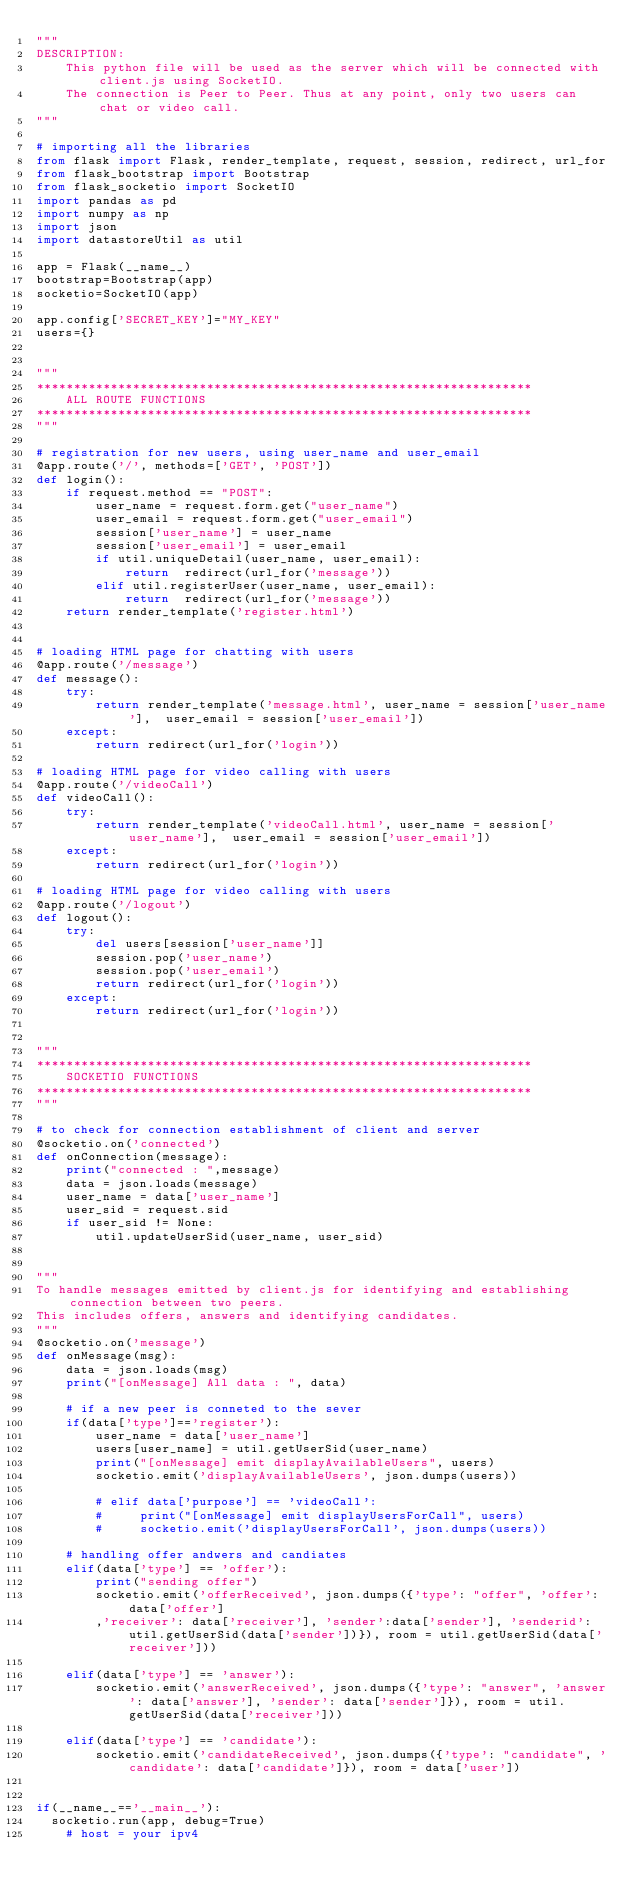<code> <loc_0><loc_0><loc_500><loc_500><_Python_>"""
DESCRIPTION:
    This python file will be used as the server which will be connected with client.js using SocketIO.
    The connection is Peer to Peer. Thus at any point, only two users can chat or video call. 
"""

# importing all the libraries
from flask import Flask, render_template, request, session, redirect, url_for
from flask_bootstrap import Bootstrap
from flask_socketio import SocketIO
import pandas as pd
import numpy as np
import json
import datastoreUtil as util

app = Flask(__name__)
bootstrap=Bootstrap(app)
socketio=SocketIO(app)

app.config['SECRET_KEY']="MY_KEY"
users={}


"""
*******************************************************************
    ALL ROUTE FUNCTIONS 
*******************************************************************
"""

# registration for new users, using user_name and user_email
@app.route('/', methods=['GET', 'POST'])
def login():
    if request.method == "POST":
        user_name = request.form.get("user_name")
        user_email = request.form.get("user_email")
        session['user_name'] = user_name
        session['user_email'] = user_email
        if util.uniqueDetail(user_name, user_email):
            return  redirect(url_for('message'))
        elif util.registerUser(user_name, user_email):
            return  redirect(url_for('message'))
    return render_template('register.html')


# loading HTML page for chatting with users 
@app.route('/message')
def message():
    try:
        return render_template('message.html', user_name = session['user_name'],  user_email = session['user_email'])
    except:
        return redirect(url_for('login'))

# loading HTML page for video calling with users 
@app.route('/videoCall')
def videoCall():
    try:
        return render_template('videoCall.html', user_name = session['user_name'],  user_email = session['user_email'])
    except:
        return redirect(url_for('login'))

# loading HTML page for video calling with users 
@app.route('/logout')
def logout():
    try:
        del users[session['user_name']]
        session.pop('user_name')
        session.pop('user_email')
        return redirect(url_for('login'))
    except:
        return redirect(url_for('login'))


"""
*******************************************************************
    SOCKETIO FUNCTIONS
*******************************************************************
"""

# to check for connection establishment of client and server
@socketio.on('connected')
def onConnection(message):    
    print("connected : ",message)
    data = json.loads(message)
    user_name = data['user_name']
    user_sid = request.sid
    if user_sid != None:
        util.updateUserSid(user_name, user_sid)


""" 
To handle messages emitted by client.js for identifying and establishing connection between two peers.
This includes offers, answers and identifying candidates.
"""
@socketio.on('message')
def onMessage(msg):
    data = json.loads(msg)
    print("[onMessage] All data : ", data)

    # if a new peer is conneted to the sever
    if(data['type']=='register'):        
        user_name = data['user_name']
        users[user_name] = util.getUserSid(user_name)
        print("[onMessage] emit displayAvailableUsers", users)
        socketio.emit('displayAvailableUsers', json.dumps(users))

        # elif data['purpose'] == 'videoCall':
        #     print("[onMessage] emit displayUsersForCall", users)
        #     socketio.emit('displayUsersForCall', json.dumps(users))

    # handling offer andwers and candiates
    elif(data['type'] == 'offer'):
        print("sending offer")
        socketio.emit('offerReceived', json.dumps({'type': "offer", 'offer': data['offer']
        ,'receiver': data['receiver'], 'sender':data['sender'], 'senderid': util.getUserSid(data['sender'])}), room = util.getUserSid(data['receiver']))

    elif(data['type'] == 'answer'):
        socketio.emit('answerReceived', json.dumps({'type': "answer", 'answer': data['answer'], 'sender': data['sender']}), room = util.getUserSid(data['receiver']))

    elif(data['type'] == 'candidate'):
        socketio.emit('candidateReceived', json.dumps({'type': "candidate", 'candidate': data['candidate']}), room = data['user'])


if(__name__=='__main__'):
	socketio.run(app, debug=True)
    # host = your ipv4
</code> 